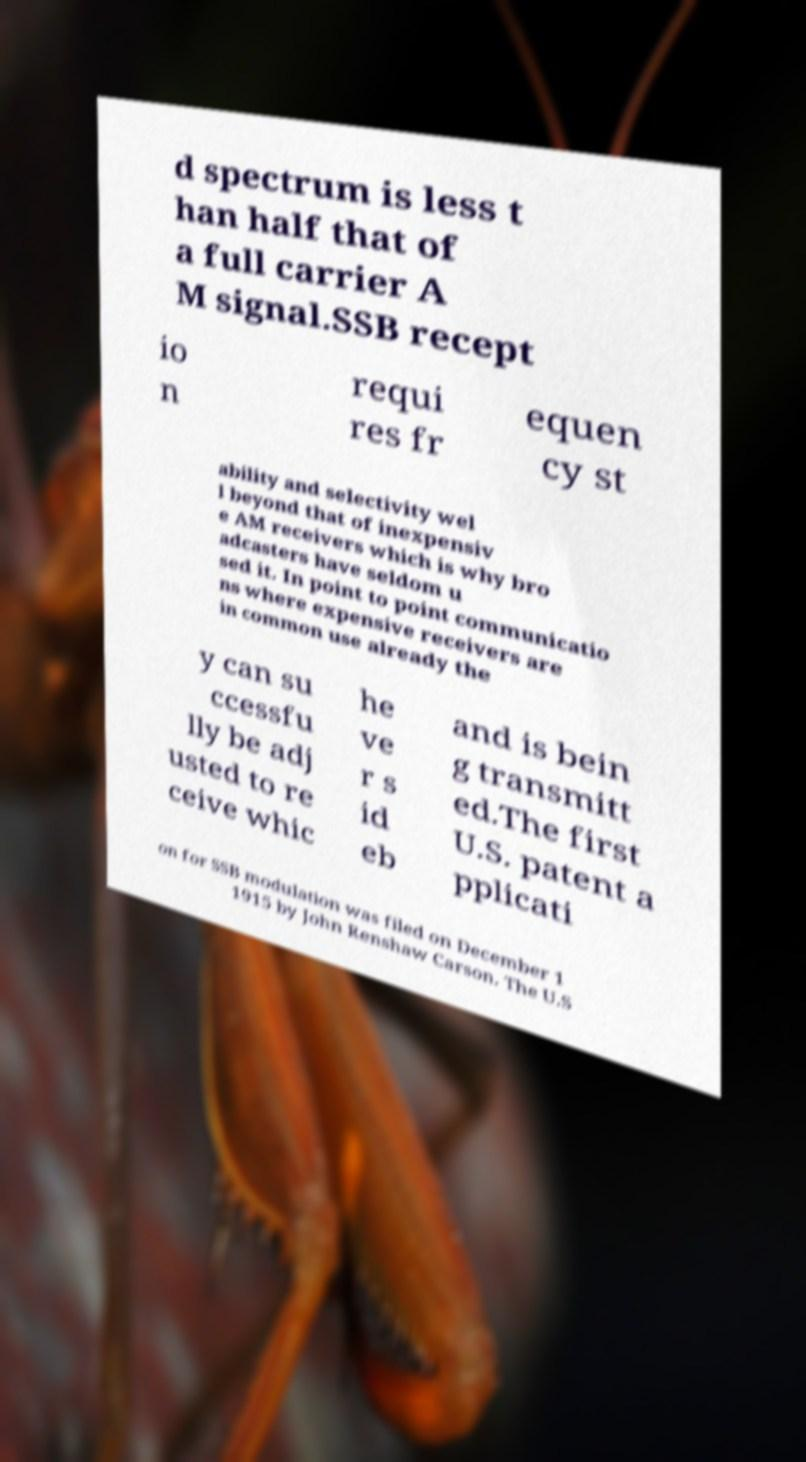Please read and relay the text visible in this image. What does it say? d spectrum is less t han half that of a full carrier A M signal.SSB recept io n requi res fr equen cy st ability and selectivity wel l beyond that of inexpensiv e AM receivers which is why bro adcasters have seldom u sed it. In point to point communicatio ns where expensive receivers are in common use already the y can su ccessfu lly be adj usted to re ceive whic he ve r s id eb and is bein g transmitt ed.The first U.S. patent a pplicati on for SSB modulation was filed on December 1 1915 by John Renshaw Carson. The U.S 